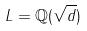<formula> <loc_0><loc_0><loc_500><loc_500>L = \mathbb { Q } ( \sqrt { d } )</formula> 